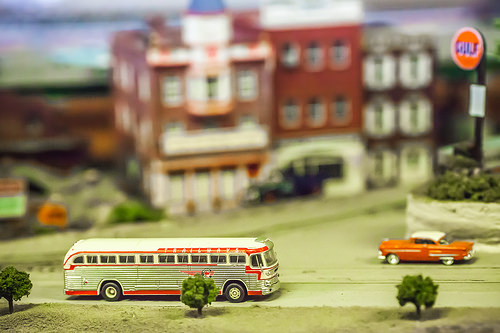<image>
Is there a bus in front of the building? Yes. The bus is positioned in front of the building, appearing closer to the camera viewpoint. 